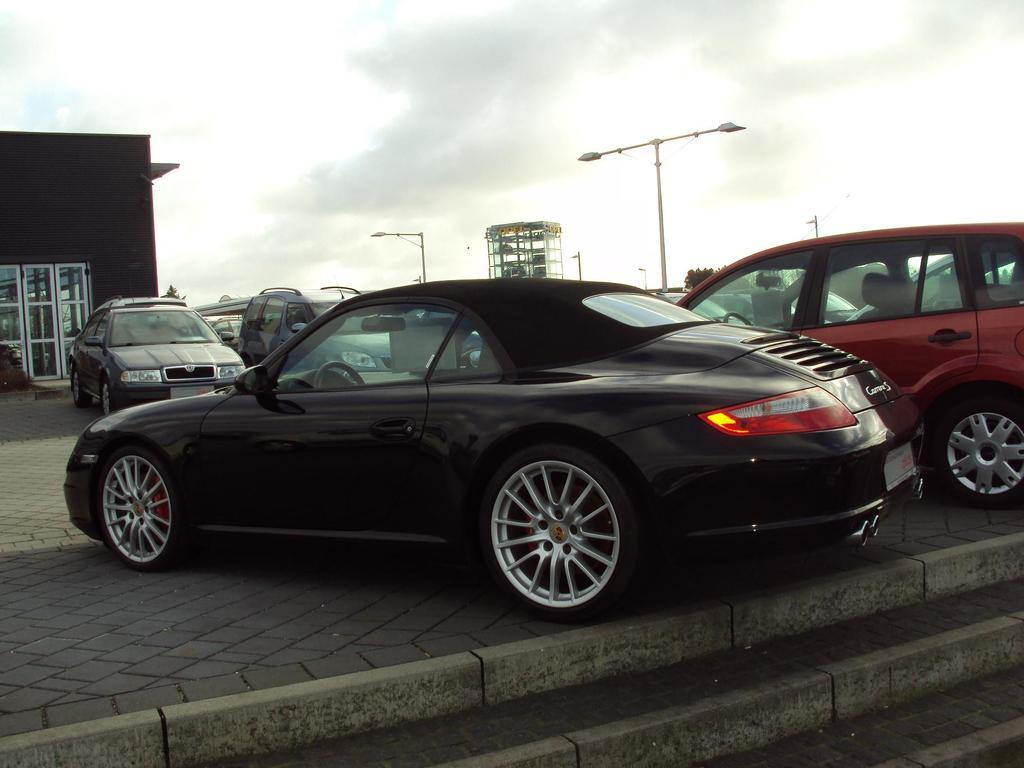What type of vehicles can be seen in the image? There are cars in the image. What structure is visible in the background of the image? There is a building in the background of the image. What else can be seen in the background of the image? There are light poles in the background of the image. What is visible at the top of the image? The sky is visible in the background of the image. Where is the crib located in the image? There is no crib present in the image. What type of control is being used to operate the cars in the image? The image does not show any controls for operating the cars; it is a still image. 